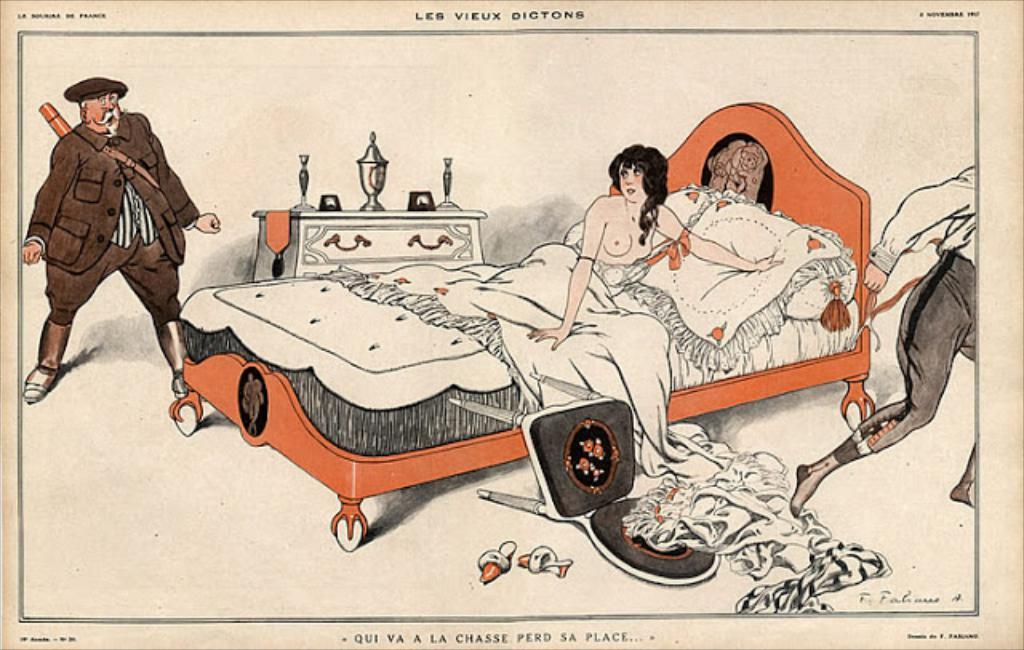What is the woman in the image doing? The woman is laying on the bed. What covers the bed in the image? The bed has a bed-sheet. How many people are in the image? There are two people in the image. What type of footwear is on the ground? There are sandals on the ground. What piece of furniture is on the ground? There is a chair on the ground. What is on the table in the image? There is a trophy on the table. What else can be seen on the table? There are objects on the table. What type of spark can be seen coming from the trophy in the image? There is no spark coming from the trophy in the image. 